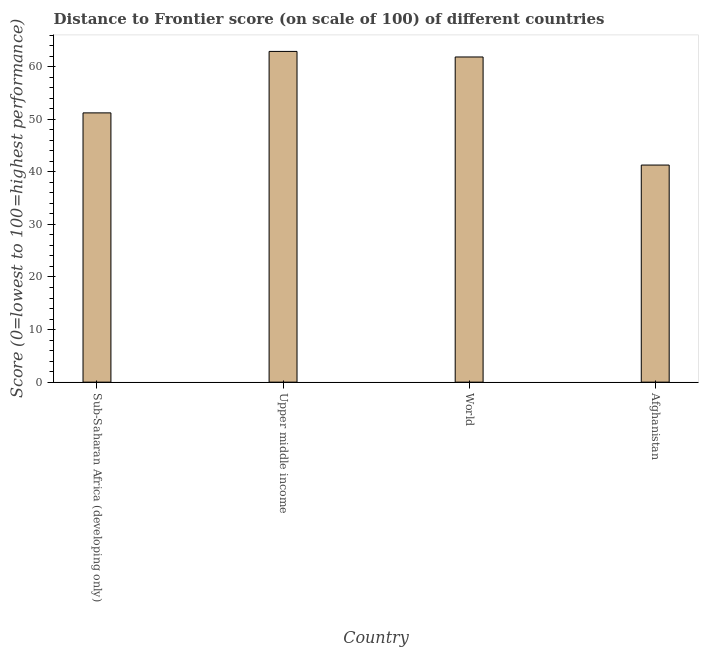Does the graph contain any zero values?
Your answer should be compact. No. What is the title of the graph?
Your answer should be compact. Distance to Frontier score (on scale of 100) of different countries. What is the label or title of the Y-axis?
Give a very brief answer. Score (0=lowest to 100=highest performance). What is the distance to frontier score in Upper middle income?
Provide a short and direct response. 62.89. Across all countries, what is the maximum distance to frontier score?
Ensure brevity in your answer.  62.89. Across all countries, what is the minimum distance to frontier score?
Your answer should be compact. 41.28. In which country was the distance to frontier score maximum?
Offer a very short reply. Upper middle income. In which country was the distance to frontier score minimum?
Provide a short and direct response. Afghanistan. What is the sum of the distance to frontier score?
Offer a very short reply. 217.2. What is the difference between the distance to frontier score in Sub-Saharan Africa (developing only) and Upper middle income?
Give a very brief answer. -11.69. What is the average distance to frontier score per country?
Your answer should be very brief. 54.3. What is the median distance to frontier score?
Provide a short and direct response. 56.52. What is the ratio of the distance to frontier score in Afghanistan to that in Upper middle income?
Your answer should be compact. 0.66. Is the distance to frontier score in Sub-Saharan Africa (developing only) less than that in Upper middle income?
Your response must be concise. Yes. What is the difference between the highest and the second highest distance to frontier score?
Give a very brief answer. 1.06. Is the sum of the distance to frontier score in Sub-Saharan Africa (developing only) and World greater than the maximum distance to frontier score across all countries?
Your answer should be compact. Yes. What is the difference between the highest and the lowest distance to frontier score?
Keep it short and to the point. 21.61. How many countries are there in the graph?
Keep it short and to the point. 4. What is the difference between two consecutive major ticks on the Y-axis?
Ensure brevity in your answer.  10. Are the values on the major ticks of Y-axis written in scientific E-notation?
Your response must be concise. No. What is the Score (0=lowest to 100=highest performance) of Sub-Saharan Africa (developing only)?
Give a very brief answer. 51.2. What is the Score (0=lowest to 100=highest performance) of Upper middle income?
Ensure brevity in your answer.  62.89. What is the Score (0=lowest to 100=highest performance) of World?
Provide a short and direct response. 61.83. What is the Score (0=lowest to 100=highest performance) in Afghanistan?
Your answer should be compact. 41.28. What is the difference between the Score (0=lowest to 100=highest performance) in Sub-Saharan Africa (developing only) and Upper middle income?
Your answer should be very brief. -11.69. What is the difference between the Score (0=lowest to 100=highest performance) in Sub-Saharan Africa (developing only) and World?
Your answer should be very brief. -10.63. What is the difference between the Score (0=lowest to 100=highest performance) in Sub-Saharan Africa (developing only) and Afghanistan?
Provide a succinct answer. 9.92. What is the difference between the Score (0=lowest to 100=highest performance) in Upper middle income and World?
Ensure brevity in your answer.  1.06. What is the difference between the Score (0=lowest to 100=highest performance) in Upper middle income and Afghanistan?
Ensure brevity in your answer.  21.61. What is the difference between the Score (0=lowest to 100=highest performance) in World and Afghanistan?
Your response must be concise. 20.55. What is the ratio of the Score (0=lowest to 100=highest performance) in Sub-Saharan Africa (developing only) to that in Upper middle income?
Your answer should be compact. 0.81. What is the ratio of the Score (0=lowest to 100=highest performance) in Sub-Saharan Africa (developing only) to that in World?
Give a very brief answer. 0.83. What is the ratio of the Score (0=lowest to 100=highest performance) in Sub-Saharan Africa (developing only) to that in Afghanistan?
Give a very brief answer. 1.24. What is the ratio of the Score (0=lowest to 100=highest performance) in Upper middle income to that in World?
Your answer should be very brief. 1.02. What is the ratio of the Score (0=lowest to 100=highest performance) in Upper middle income to that in Afghanistan?
Your response must be concise. 1.52. What is the ratio of the Score (0=lowest to 100=highest performance) in World to that in Afghanistan?
Your answer should be very brief. 1.5. 